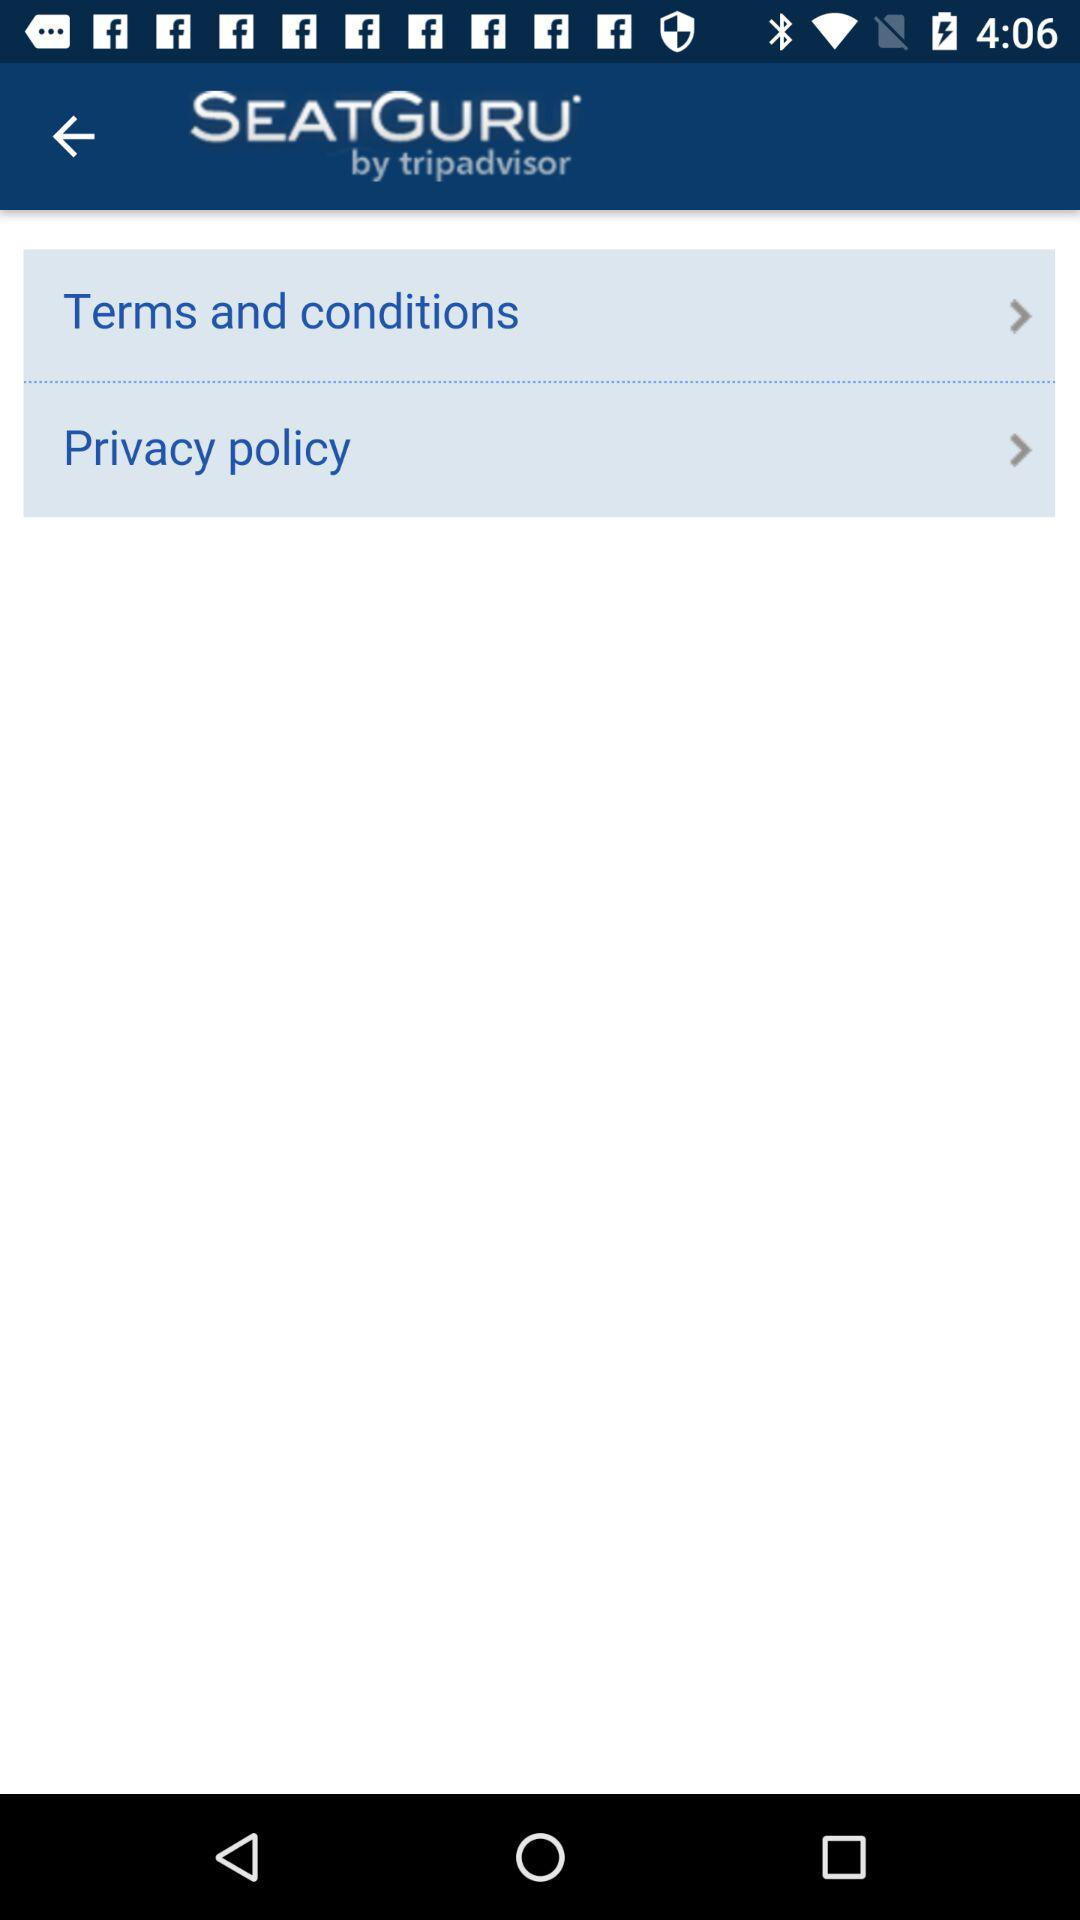Who created the application? The application was created by "tripadvisor". 